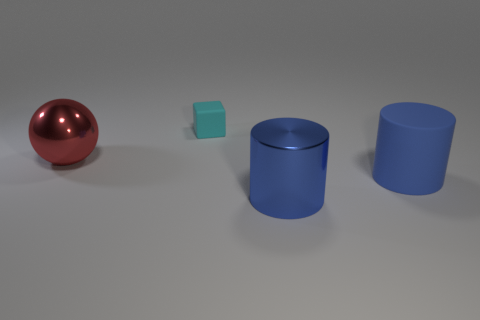Add 1 big yellow metal blocks. How many objects exist? 5 Subtract all spheres. How many objects are left? 3 Add 4 cyan matte blocks. How many cyan matte blocks are left? 5 Add 3 tiny purple matte spheres. How many tiny purple matte spheres exist? 3 Subtract 0 gray balls. How many objects are left? 4 Subtract all small objects. Subtract all big gray spheres. How many objects are left? 3 